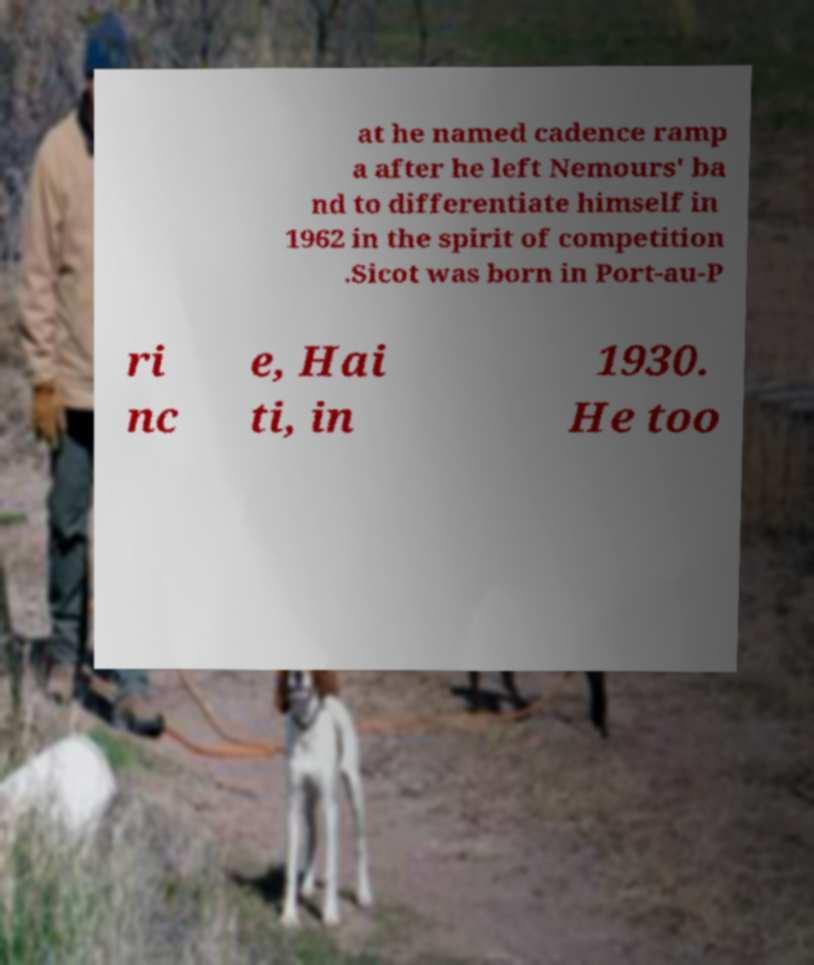There's text embedded in this image that I need extracted. Can you transcribe it verbatim? at he named cadence ramp a after he left Nemours' ba nd to differentiate himself in 1962 in the spirit of competition .Sicot was born in Port-au-P ri nc e, Hai ti, in 1930. He too 